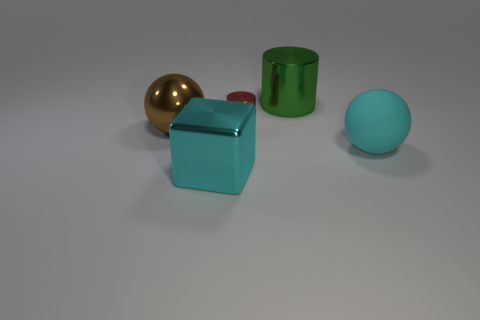Add 4 big cyan shiny objects. How many objects exist? 9 Subtract all cylinders. How many objects are left? 3 Subtract 1 cyan balls. How many objects are left? 4 Subtract all large green matte objects. Subtract all shiny cylinders. How many objects are left? 3 Add 1 tiny red shiny cylinders. How many tiny red shiny cylinders are left? 2 Add 5 matte spheres. How many matte spheres exist? 6 